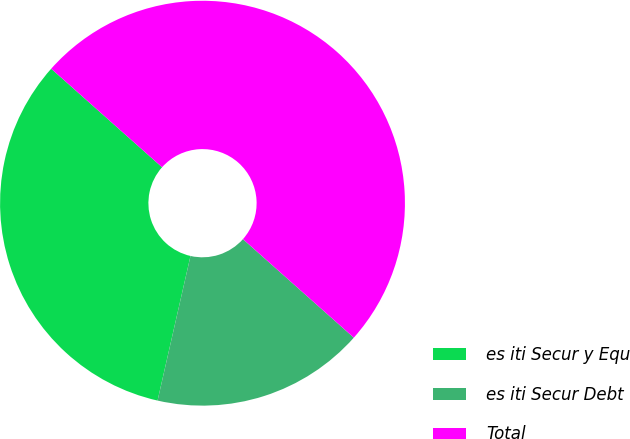Convert chart. <chart><loc_0><loc_0><loc_500><loc_500><pie_chart><fcel>es iti Secur y Equ<fcel>es iti Secur Debt<fcel>Total<nl><fcel>33.0%<fcel>17.0%<fcel>50.0%<nl></chart> 